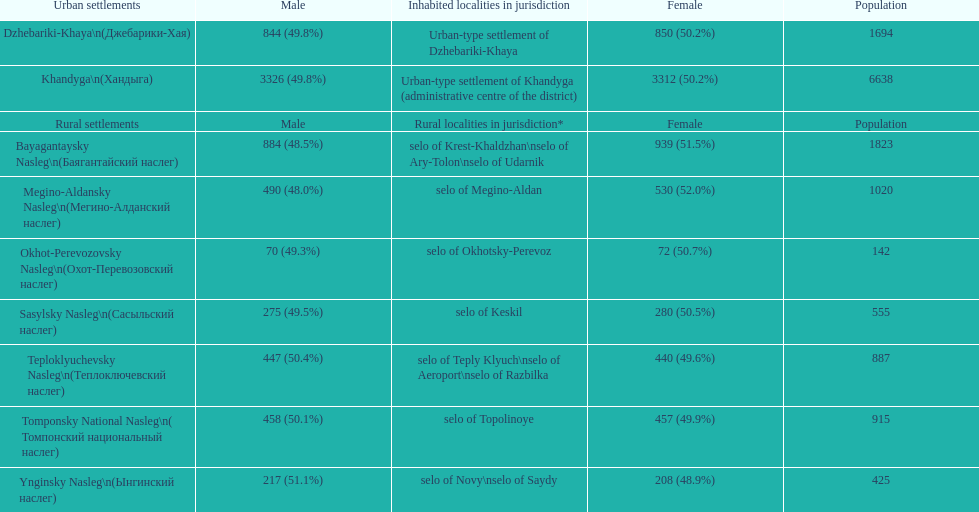Parse the table in full. {'header': ['Urban settlements', 'Male', 'Inhabited localities in jurisdiction', 'Female', 'Population'], 'rows': [['Dzhebariki-Khaya\\n(Джебарики-Хая)', '844 (49.8%)', 'Urban-type settlement of Dzhebariki-Khaya', '850 (50.2%)', '1694'], ['Khandyga\\n(Хандыга)', '3326 (49.8%)', 'Urban-type settlement of Khandyga (administrative centre of the district)', '3312 (50.2%)', '6638'], ['Rural settlements', 'Male', 'Rural localities in jurisdiction*', 'Female', 'Population'], ['Bayagantaysky Nasleg\\n(Баягантайский наслег)', '884 (48.5%)', 'selo of Krest-Khaldzhan\\nselo of Ary-Tolon\\nselo of Udarnik', '939 (51.5%)', '1823'], ['Megino-Aldansky Nasleg\\n(Мегино-Алданский наслег)', '490 (48.0%)', 'selo of Megino-Aldan', '530 (52.0%)', '1020'], ['Okhot-Perevozovsky Nasleg\\n(Охот-Перевозовский наслег)', '70 (49.3%)', 'selo of Okhotsky-Perevoz', '72 (50.7%)', '142'], ['Sasylsky Nasleg\\n(Сасыльский наслег)', '275 (49.5%)', 'selo of Keskil', '280 (50.5%)', '555'], ['Teploklyuchevsky Nasleg\\n(Теплоключевский наслег)', '447 (50.4%)', 'selo of Teply Klyuch\\nselo of Aeroport\\nselo of Razbilka', '440 (49.6%)', '887'], ['Tomponsky National Nasleg\\n( Томпонский национальный наслег)', '458 (50.1%)', 'selo of Topolinoye', '457 (49.9%)', '915'], ['Ynginsky Nasleg\\n(Ынгинский наслег)', '217 (51.1%)', 'selo of Novy\\nselo of Saydy', '208 (48.9%)', '425']]} What is the total population in dzhebariki-khaya? 1694. 